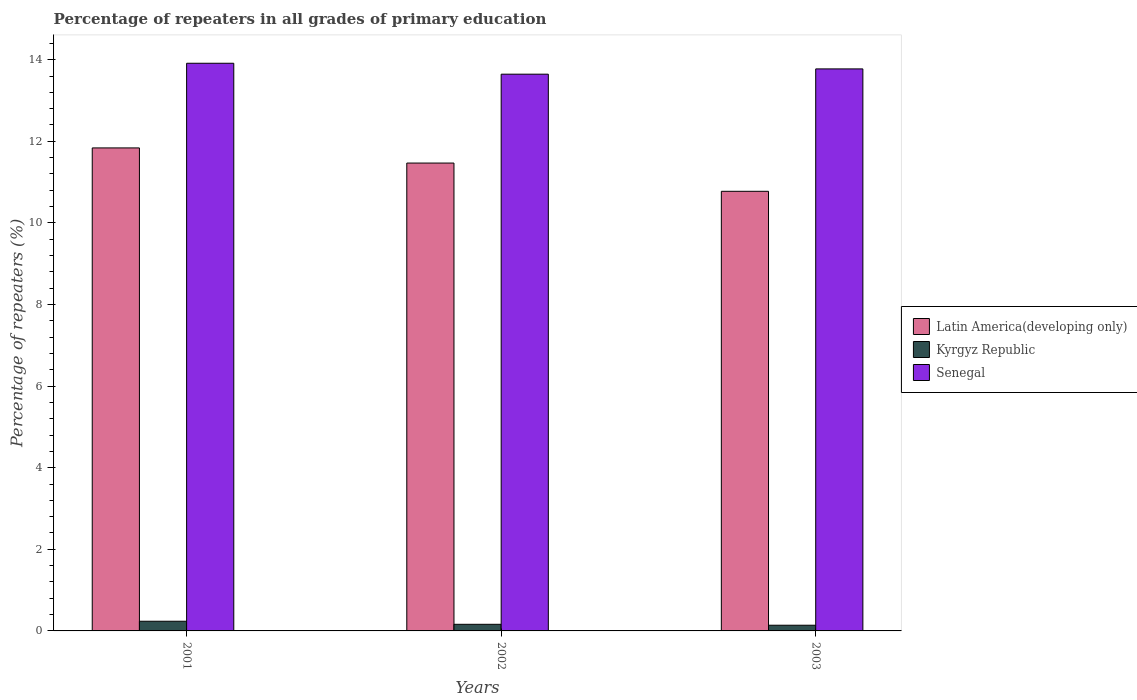How many groups of bars are there?
Offer a very short reply. 3. How many bars are there on the 1st tick from the left?
Provide a succinct answer. 3. What is the label of the 2nd group of bars from the left?
Make the answer very short. 2002. What is the percentage of repeaters in Senegal in 2002?
Ensure brevity in your answer.  13.65. Across all years, what is the maximum percentage of repeaters in Latin America(developing only)?
Ensure brevity in your answer.  11.84. Across all years, what is the minimum percentage of repeaters in Kyrgyz Republic?
Keep it short and to the point. 0.14. In which year was the percentage of repeaters in Kyrgyz Republic minimum?
Offer a very short reply. 2003. What is the total percentage of repeaters in Senegal in the graph?
Provide a succinct answer. 41.33. What is the difference between the percentage of repeaters in Kyrgyz Republic in 2001 and that in 2002?
Give a very brief answer. 0.07. What is the difference between the percentage of repeaters in Senegal in 2003 and the percentage of repeaters in Kyrgyz Republic in 2002?
Give a very brief answer. 13.61. What is the average percentage of repeaters in Senegal per year?
Make the answer very short. 13.78. In the year 2003, what is the difference between the percentage of repeaters in Kyrgyz Republic and percentage of repeaters in Latin America(developing only)?
Ensure brevity in your answer.  -10.63. In how many years, is the percentage of repeaters in Latin America(developing only) greater than 6 %?
Keep it short and to the point. 3. What is the ratio of the percentage of repeaters in Senegal in 2001 to that in 2003?
Your response must be concise. 1.01. Is the percentage of repeaters in Latin America(developing only) in 2001 less than that in 2002?
Make the answer very short. No. Is the difference between the percentage of repeaters in Kyrgyz Republic in 2001 and 2003 greater than the difference between the percentage of repeaters in Latin America(developing only) in 2001 and 2003?
Offer a very short reply. No. What is the difference between the highest and the second highest percentage of repeaters in Latin America(developing only)?
Your answer should be compact. 0.37. What is the difference between the highest and the lowest percentage of repeaters in Kyrgyz Republic?
Provide a succinct answer. 0.1. In how many years, is the percentage of repeaters in Kyrgyz Republic greater than the average percentage of repeaters in Kyrgyz Republic taken over all years?
Offer a terse response. 1. What does the 1st bar from the left in 2003 represents?
Offer a terse response. Latin America(developing only). What does the 1st bar from the right in 2003 represents?
Provide a succinct answer. Senegal. Is it the case that in every year, the sum of the percentage of repeaters in Senegal and percentage of repeaters in Kyrgyz Republic is greater than the percentage of repeaters in Latin America(developing only)?
Provide a short and direct response. Yes. How many bars are there?
Your answer should be very brief. 9. How many years are there in the graph?
Your answer should be very brief. 3. Does the graph contain any zero values?
Give a very brief answer. No. Where does the legend appear in the graph?
Offer a very short reply. Center right. How many legend labels are there?
Your answer should be very brief. 3. What is the title of the graph?
Offer a terse response. Percentage of repeaters in all grades of primary education. What is the label or title of the X-axis?
Offer a terse response. Years. What is the label or title of the Y-axis?
Provide a succinct answer. Percentage of repeaters (%). What is the Percentage of repeaters (%) in Latin America(developing only) in 2001?
Keep it short and to the point. 11.84. What is the Percentage of repeaters (%) of Kyrgyz Republic in 2001?
Offer a very short reply. 0.24. What is the Percentage of repeaters (%) in Senegal in 2001?
Your response must be concise. 13.91. What is the Percentage of repeaters (%) of Latin America(developing only) in 2002?
Give a very brief answer. 11.47. What is the Percentage of repeaters (%) of Kyrgyz Republic in 2002?
Offer a very short reply. 0.16. What is the Percentage of repeaters (%) of Senegal in 2002?
Your response must be concise. 13.65. What is the Percentage of repeaters (%) of Latin America(developing only) in 2003?
Your response must be concise. 10.77. What is the Percentage of repeaters (%) of Kyrgyz Republic in 2003?
Give a very brief answer. 0.14. What is the Percentage of repeaters (%) in Senegal in 2003?
Your response must be concise. 13.77. Across all years, what is the maximum Percentage of repeaters (%) of Latin America(developing only)?
Make the answer very short. 11.84. Across all years, what is the maximum Percentage of repeaters (%) of Kyrgyz Republic?
Your answer should be compact. 0.24. Across all years, what is the maximum Percentage of repeaters (%) in Senegal?
Provide a succinct answer. 13.91. Across all years, what is the minimum Percentage of repeaters (%) of Latin America(developing only)?
Offer a terse response. 10.77. Across all years, what is the minimum Percentage of repeaters (%) of Kyrgyz Republic?
Give a very brief answer. 0.14. Across all years, what is the minimum Percentage of repeaters (%) in Senegal?
Your response must be concise. 13.65. What is the total Percentage of repeaters (%) in Latin America(developing only) in the graph?
Your answer should be very brief. 34.08. What is the total Percentage of repeaters (%) of Kyrgyz Republic in the graph?
Provide a succinct answer. 0.54. What is the total Percentage of repeaters (%) in Senegal in the graph?
Your response must be concise. 41.33. What is the difference between the Percentage of repeaters (%) in Latin America(developing only) in 2001 and that in 2002?
Make the answer very short. 0.37. What is the difference between the Percentage of repeaters (%) of Kyrgyz Republic in 2001 and that in 2002?
Provide a succinct answer. 0.07. What is the difference between the Percentage of repeaters (%) of Senegal in 2001 and that in 2002?
Your answer should be very brief. 0.27. What is the difference between the Percentage of repeaters (%) of Latin America(developing only) in 2001 and that in 2003?
Make the answer very short. 1.06. What is the difference between the Percentage of repeaters (%) in Kyrgyz Republic in 2001 and that in 2003?
Offer a very short reply. 0.1. What is the difference between the Percentage of repeaters (%) in Senegal in 2001 and that in 2003?
Ensure brevity in your answer.  0.14. What is the difference between the Percentage of repeaters (%) in Latin America(developing only) in 2002 and that in 2003?
Your response must be concise. 0.69. What is the difference between the Percentage of repeaters (%) in Kyrgyz Republic in 2002 and that in 2003?
Give a very brief answer. 0.02. What is the difference between the Percentage of repeaters (%) in Senegal in 2002 and that in 2003?
Provide a short and direct response. -0.13. What is the difference between the Percentage of repeaters (%) of Latin America(developing only) in 2001 and the Percentage of repeaters (%) of Kyrgyz Republic in 2002?
Provide a succinct answer. 11.68. What is the difference between the Percentage of repeaters (%) in Latin America(developing only) in 2001 and the Percentage of repeaters (%) in Senegal in 2002?
Offer a terse response. -1.81. What is the difference between the Percentage of repeaters (%) of Kyrgyz Republic in 2001 and the Percentage of repeaters (%) of Senegal in 2002?
Your answer should be very brief. -13.41. What is the difference between the Percentage of repeaters (%) of Latin America(developing only) in 2001 and the Percentage of repeaters (%) of Kyrgyz Republic in 2003?
Offer a terse response. 11.7. What is the difference between the Percentage of repeaters (%) in Latin America(developing only) in 2001 and the Percentage of repeaters (%) in Senegal in 2003?
Your answer should be very brief. -1.94. What is the difference between the Percentage of repeaters (%) of Kyrgyz Republic in 2001 and the Percentage of repeaters (%) of Senegal in 2003?
Your response must be concise. -13.54. What is the difference between the Percentage of repeaters (%) of Latin America(developing only) in 2002 and the Percentage of repeaters (%) of Kyrgyz Republic in 2003?
Make the answer very short. 11.33. What is the difference between the Percentage of repeaters (%) of Latin America(developing only) in 2002 and the Percentage of repeaters (%) of Senegal in 2003?
Ensure brevity in your answer.  -2.31. What is the difference between the Percentage of repeaters (%) in Kyrgyz Republic in 2002 and the Percentage of repeaters (%) in Senegal in 2003?
Your answer should be compact. -13.61. What is the average Percentage of repeaters (%) in Latin America(developing only) per year?
Your response must be concise. 11.36. What is the average Percentage of repeaters (%) of Kyrgyz Republic per year?
Provide a succinct answer. 0.18. What is the average Percentage of repeaters (%) in Senegal per year?
Provide a short and direct response. 13.78. In the year 2001, what is the difference between the Percentage of repeaters (%) in Latin America(developing only) and Percentage of repeaters (%) in Kyrgyz Republic?
Offer a terse response. 11.6. In the year 2001, what is the difference between the Percentage of repeaters (%) in Latin America(developing only) and Percentage of repeaters (%) in Senegal?
Make the answer very short. -2.07. In the year 2001, what is the difference between the Percentage of repeaters (%) in Kyrgyz Republic and Percentage of repeaters (%) in Senegal?
Provide a succinct answer. -13.68. In the year 2002, what is the difference between the Percentage of repeaters (%) in Latin America(developing only) and Percentage of repeaters (%) in Kyrgyz Republic?
Your response must be concise. 11.3. In the year 2002, what is the difference between the Percentage of repeaters (%) of Latin America(developing only) and Percentage of repeaters (%) of Senegal?
Make the answer very short. -2.18. In the year 2002, what is the difference between the Percentage of repeaters (%) of Kyrgyz Republic and Percentage of repeaters (%) of Senegal?
Give a very brief answer. -13.48. In the year 2003, what is the difference between the Percentage of repeaters (%) in Latin America(developing only) and Percentage of repeaters (%) in Kyrgyz Republic?
Make the answer very short. 10.63. In the year 2003, what is the difference between the Percentage of repeaters (%) in Latin America(developing only) and Percentage of repeaters (%) in Senegal?
Keep it short and to the point. -3. In the year 2003, what is the difference between the Percentage of repeaters (%) in Kyrgyz Republic and Percentage of repeaters (%) in Senegal?
Offer a terse response. -13.63. What is the ratio of the Percentage of repeaters (%) in Latin America(developing only) in 2001 to that in 2002?
Give a very brief answer. 1.03. What is the ratio of the Percentage of repeaters (%) of Kyrgyz Republic in 2001 to that in 2002?
Your response must be concise. 1.46. What is the ratio of the Percentage of repeaters (%) in Senegal in 2001 to that in 2002?
Offer a very short reply. 1.02. What is the ratio of the Percentage of repeaters (%) in Latin America(developing only) in 2001 to that in 2003?
Offer a terse response. 1.1. What is the ratio of the Percentage of repeaters (%) in Kyrgyz Republic in 2001 to that in 2003?
Provide a short and direct response. 1.7. What is the ratio of the Percentage of repeaters (%) of Latin America(developing only) in 2002 to that in 2003?
Offer a terse response. 1.06. What is the ratio of the Percentage of repeaters (%) of Kyrgyz Republic in 2002 to that in 2003?
Your response must be concise. 1.16. What is the ratio of the Percentage of repeaters (%) of Senegal in 2002 to that in 2003?
Ensure brevity in your answer.  0.99. What is the difference between the highest and the second highest Percentage of repeaters (%) of Latin America(developing only)?
Offer a very short reply. 0.37. What is the difference between the highest and the second highest Percentage of repeaters (%) of Kyrgyz Republic?
Keep it short and to the point. 0.07. What is the difference between the highest and the second highest Percentage of repeaters (%) of Senegal?
Your response must be concise. 0.14. What is the difference between the highest and the lowest Percentage of repeaters (%) in Latin America(developing only)?
Your response must be concise. 1.06. What is the difference between the highest and the lowest Percentage of repeaters (%) of Kyrgyz Republic?
Your answer should be compact. 0.1. What is the difference between the highest and the lowest Percentage of repeaters (%) in Senegal?
Your answer should be very brief. 0.27. 